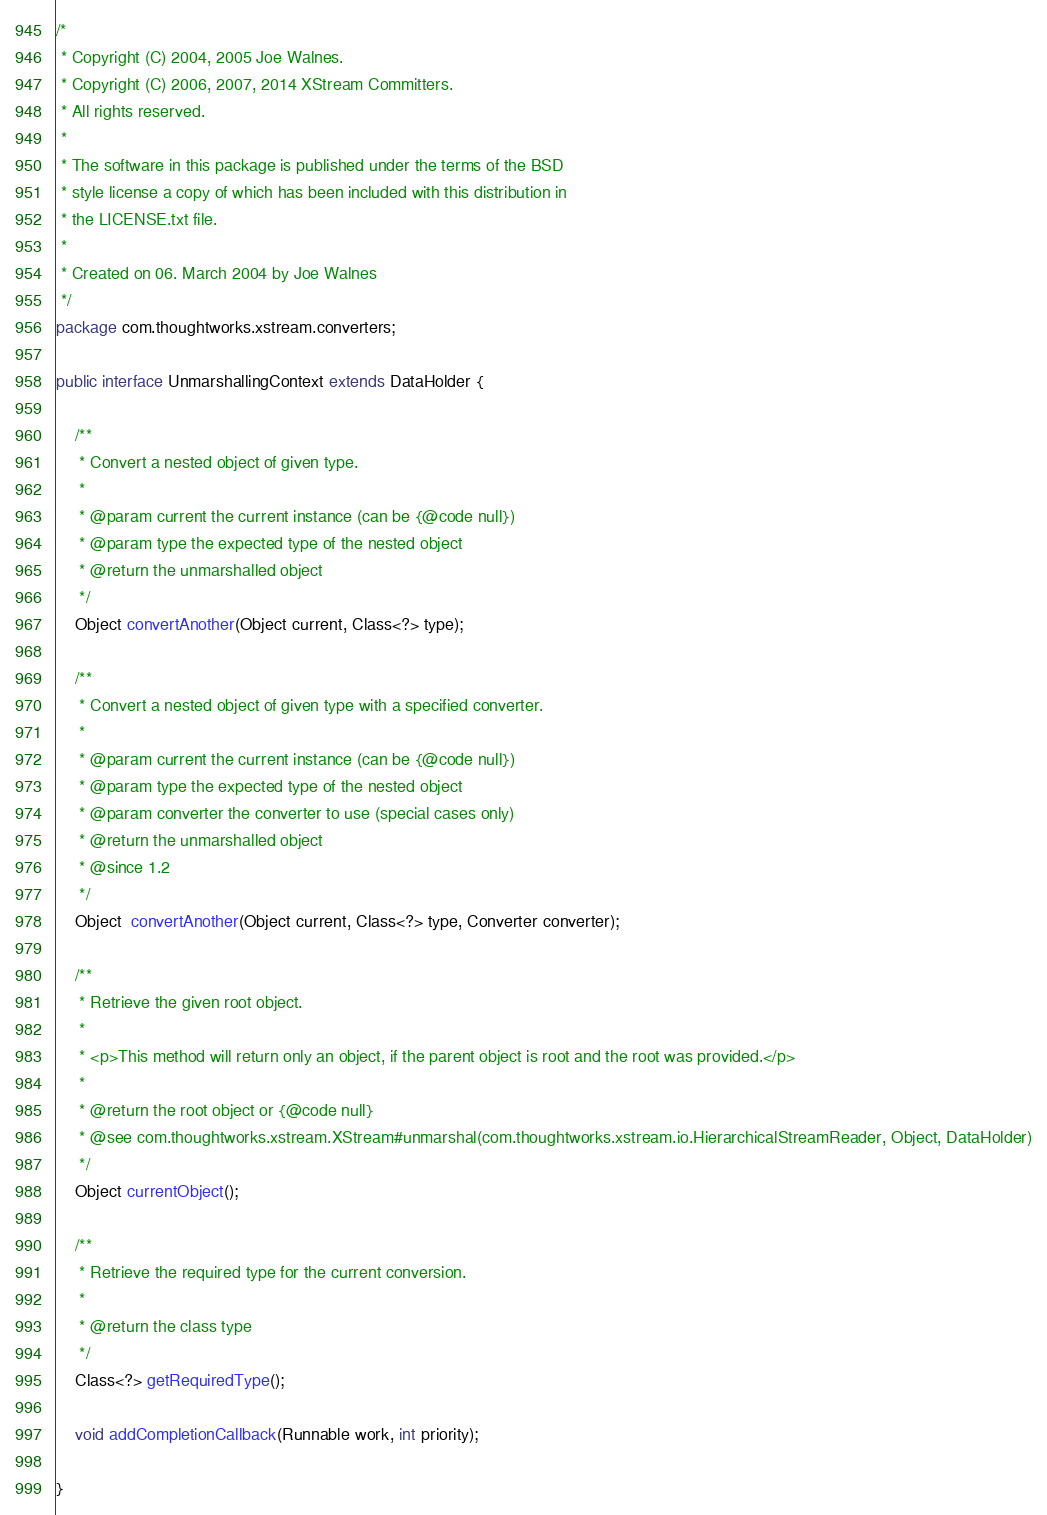Convert code to text. <code><loc_0><loc_0><loc_500><loc_500><_Java_>/*
 * Copyright (C) 2004, 2005 Joe Walnes.
 * Copyright (C) 2006, 2007, 2014 XStream Committers.
 * All rights reserved.
 *
 * The software in this package is published under the terms of the BSD
 * style license a copy of which has been included with this distribution in
 * the LICENSE.txt file.
 * 
 * Created on 06. March 2004 by Joe Walnes
 */
package com.thoughtworks.xstream.converters;

public interface UnmarshallingContext extends DataHolder {

    /**
     * Convert a nested object of given type.
     * 
     * @param current the current instance (can be {@code null})
     * @param type the expected type of the nested object
     * @return the unmarshalled object
     */
    Object convertAnother(Object current, Class<?> type);

    /**
     * Convert a nested object of given type with a specified converter.
     * 
     * @param current the current instance (can be {@code null})
     * @param type the expected type of the nested object
     * @param converter the converter to use (special cases only)
     * @return the unmarshalled object
     * @since 1.2
     */
    Object  convertAnother(Object current, Class<?> type, Converter converter);

    /**
     * Retrieve the given root object.
     * 
     * <p>This method will return only an object, if the parent object is root and the root was provided.</p>
     * 
     * @return the root object or {@code null}
     * @see com.thoughtworks.xstream.XStream#unmarshal(com.thoughtworks.xstream.io.HierarchicalStreamReader, Object, DataHolder)
     */
    Object currentObject();

    /**
     * Retrieve the required type for the current conversion.
     * 
     * @return the class type
     */
    Class<?> getRequiredType();

    void addCompletionCallback(Runnable work, int priority);

}
</code> 